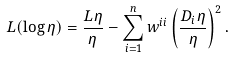<formula> <loc_0><loc_0><loc_500><loc_500>L ( \log \eta ) = \frac { L \eta } { \eta } - \sum _ { i = 1 } ^ { n } w ^ { i i } \left ( \frac { D _ { i } \eta } { \eta } \right ) ^ { 2 } .</formula> 